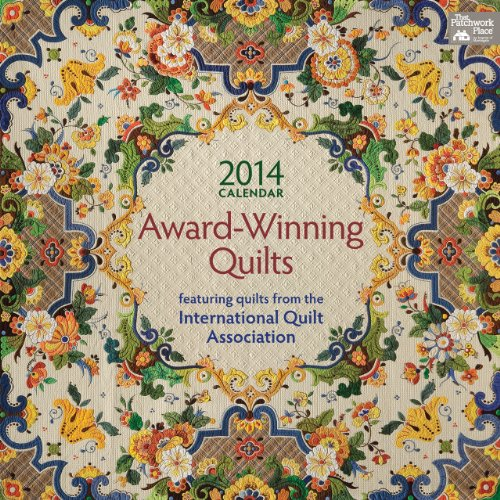What might be the significance of quilts being featured in an international association's calendar? Featuring quilts in an international association's calendar highlights their artistic and cultural value, showcasing them not just as crafts, but as art pieces that reflect individual and community craftsmanship at a global scale. How does one get their quilt featured in such a calendar? Quilters would typically enter their works in competitions organized or recognized by the International Quilt Association. Winners or notable entries from these competitions might then be selected to appear in the calendar. 